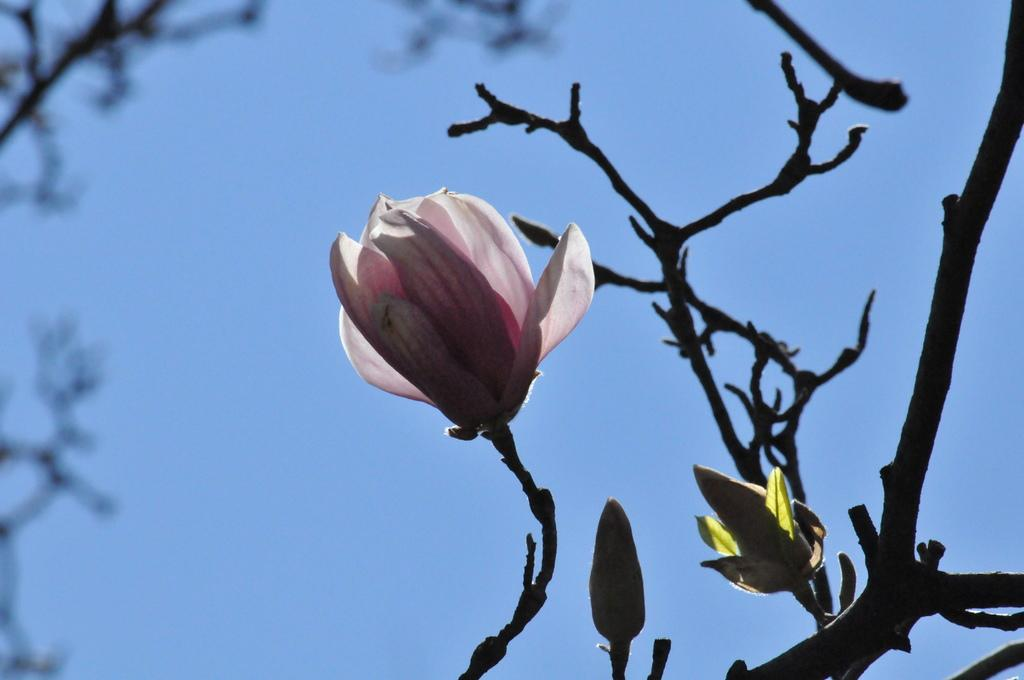What type of plant can be seen in the image? There is a flower on a tree in the image. Are there any other parts of the tree visible in the image? Yes, there are two buds on the tree in the image. What is visible in the background of the image? There is a sky visible in the background of the image. What type of knot is being used to tie the branches of the tree together in the image? There is no knot visible in the image; it is a tree with a flower and buds. What type of school can be seen in the image? There is no school present in the image; it is a tree with a flower and buds. 